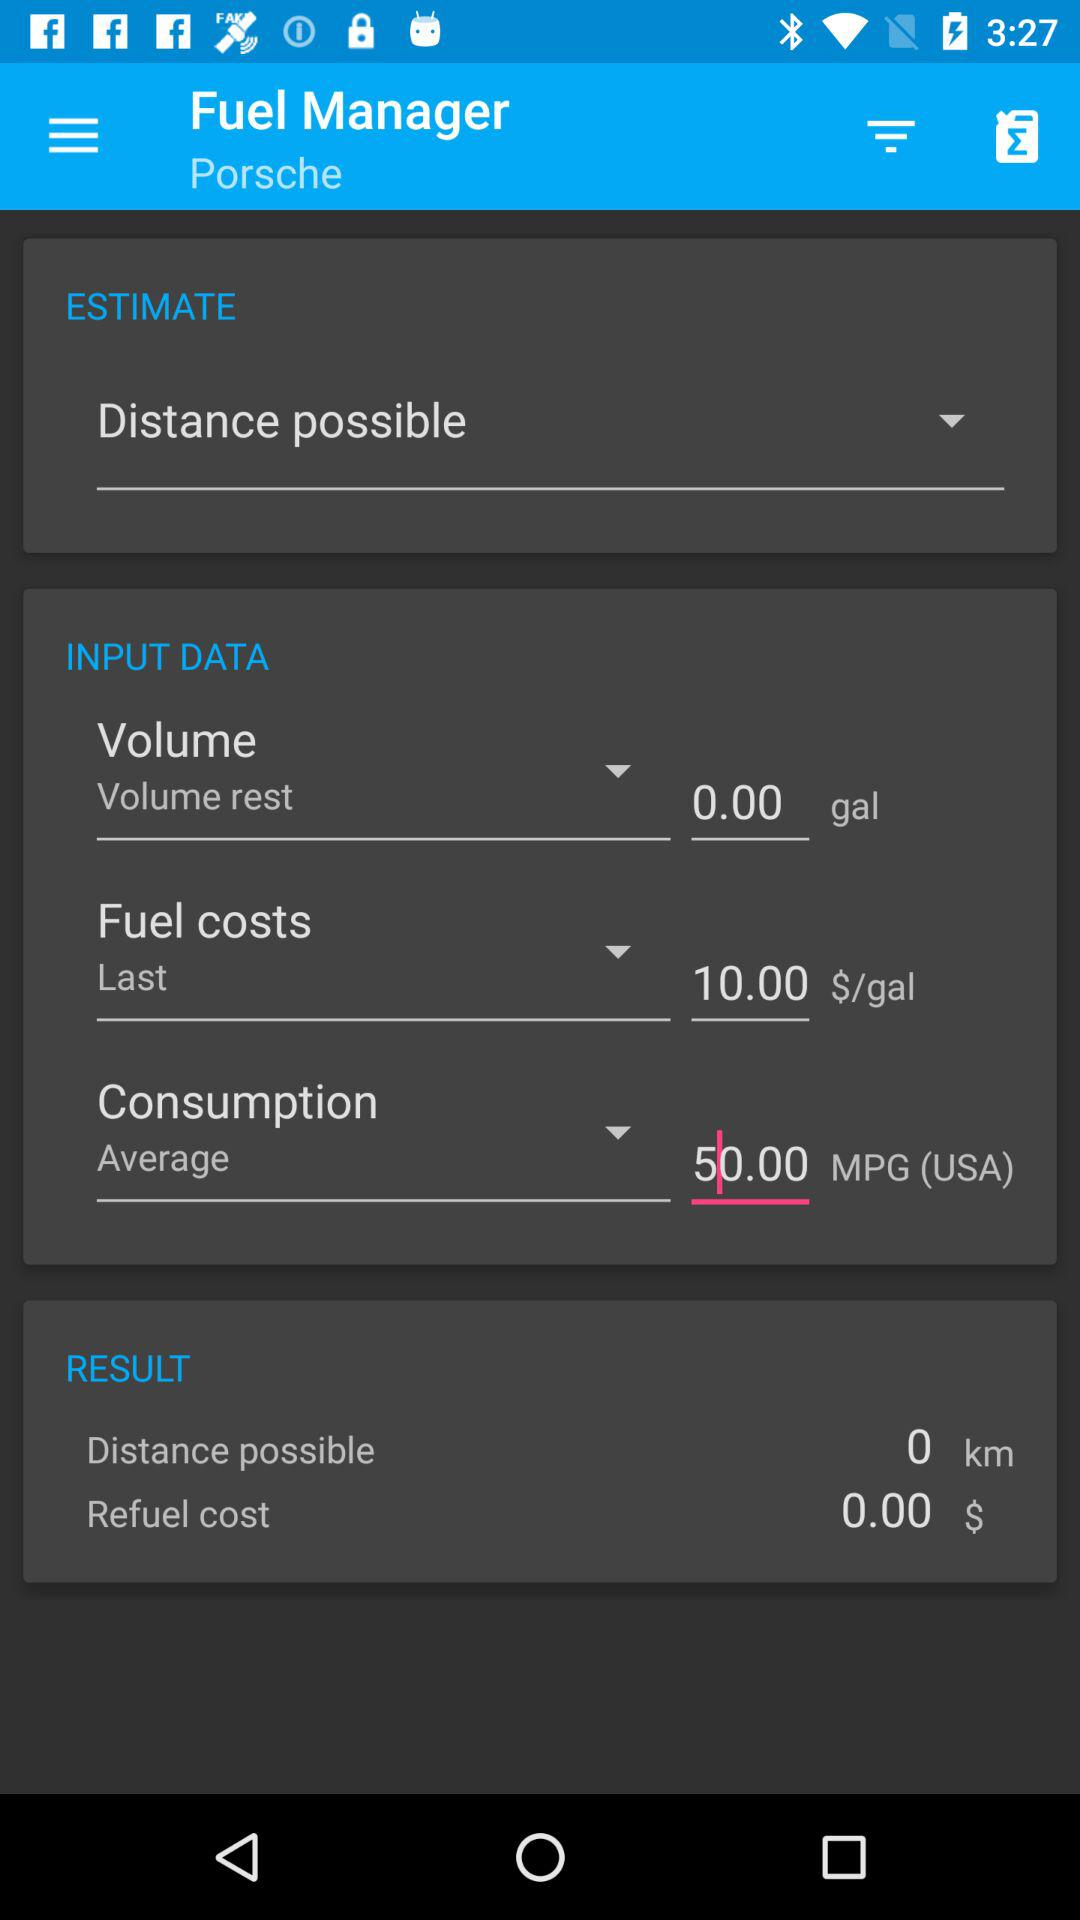How much does refuelling cost? The refuelling cost is $0.00. 